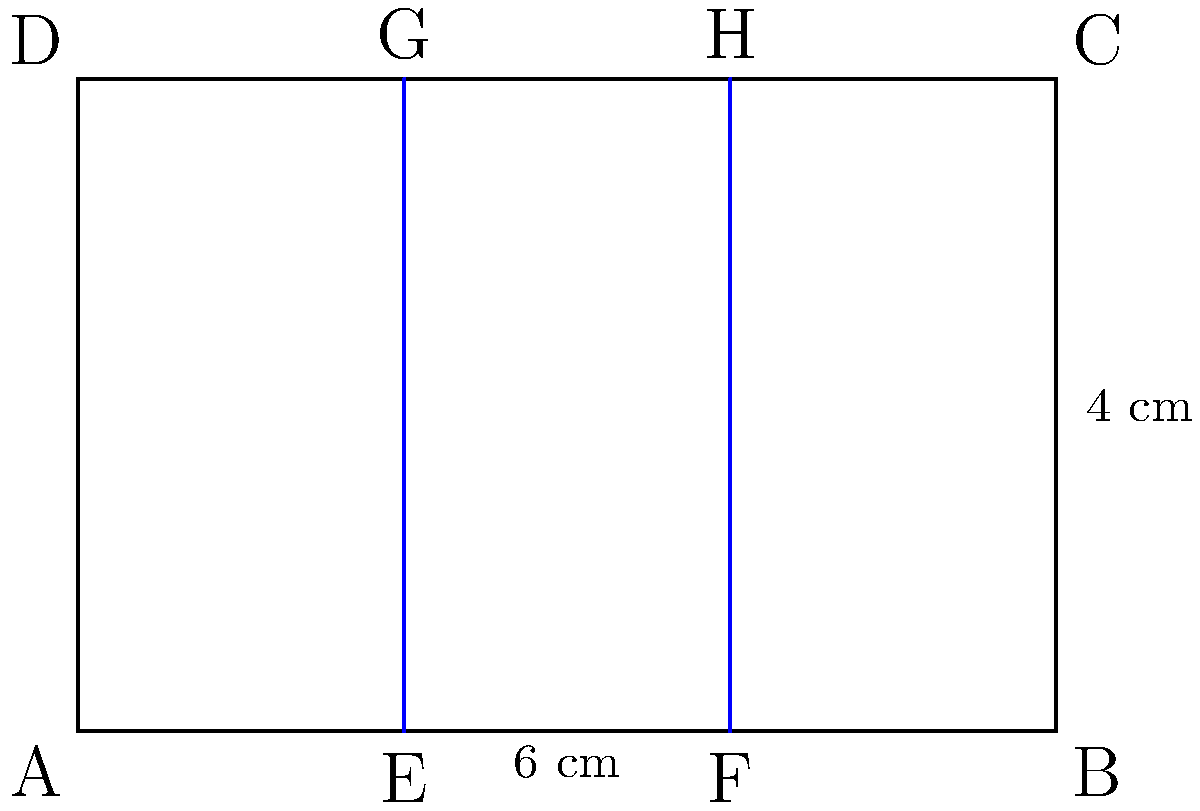In the diagram above, a cross-section of an airplane seat row is represented by a rectangle ABCD. Two armrests are shown as vertical lines EG and FH. If the total width of the seat row is 6 cm and the armrests are placed symmetrically, what is the width of the middle seat in centimeters? To find the width of the middle seat, we need to follow these steps:

1) First, let's identify the important information:
   - The total width of the seat row (ABCD) is 6 cm
   - There are two armrests (EG and FH) placed symmetrically

2) Since the armrests are placed symmetrically, we can divide the total width into three equal parts:
   $$ \text{Width of each part} = \frac{\text{Total width}}{3} = \frac{6 \text{ cm}}{3} = 2 \text{ cm} $$

3) The middle seat is located between the two armrests (EG and FH). Its width is equal to the distance between these two lines.

4) The distance between E and F is equal to one of the three equal parts we calculated:
   $$ \text{Width of middle seat} = EF = 2 \text{ cm} $$

Therefore, the width of the middle seat is 2 cm.
Answer: 2 cm 